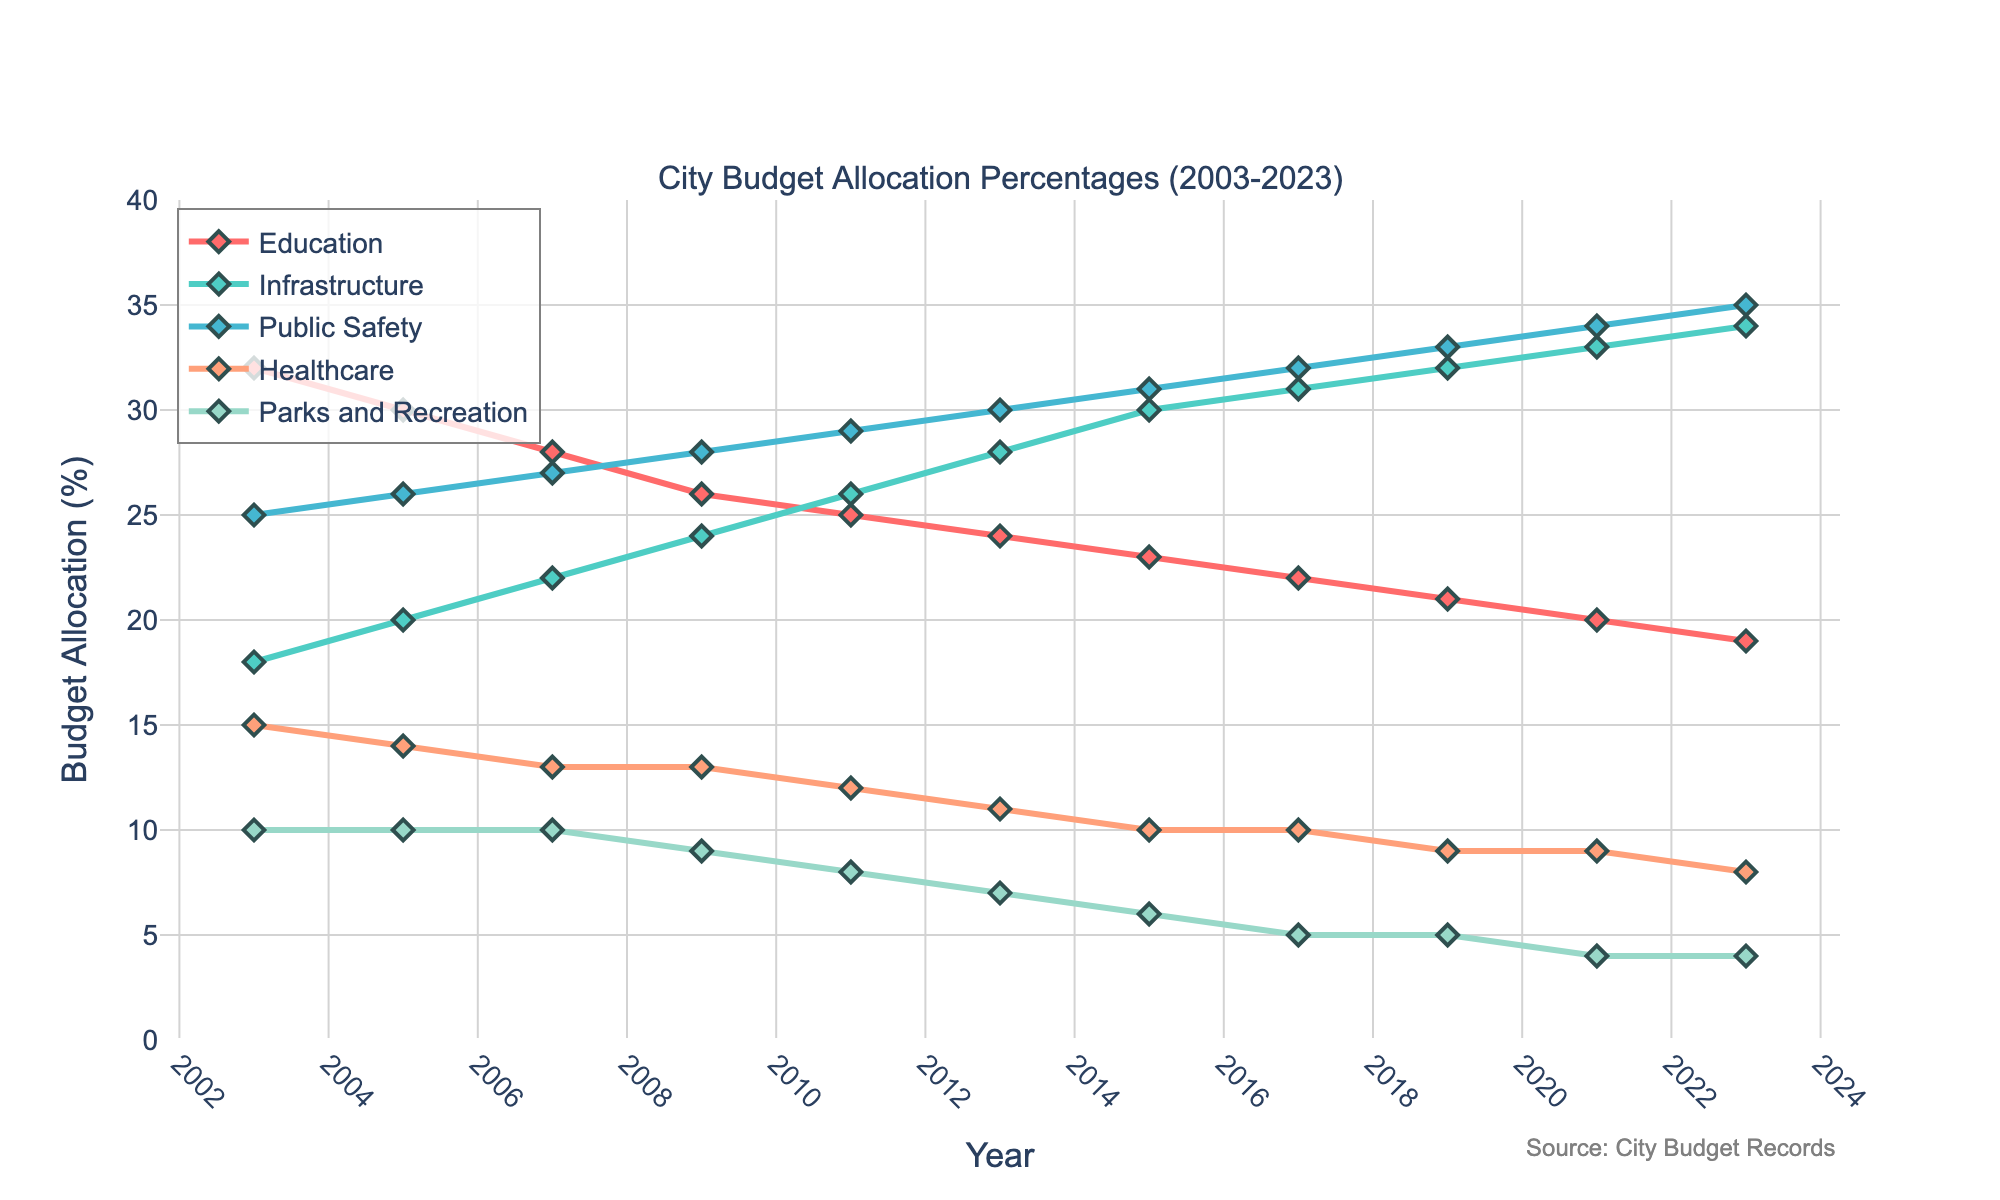What's the trend in budget allocation for the Education sector over the 20 years? The Education sector shows a consistently decreasing trend in budget allocation percentages, starting at 32% in 2003 and decreasing steadily to 19% in 2023.
Answer: Decreasing trend Which sector has seen the most significant increase in budget allocation from 2003 to 2023? Public Safety has seen the most significant increase in budget allocation, rising from 25% in 2003 to 35% in 2023, an increase of 10 percentage points.
Answer: Public Safety In which year did Infrastructure surpass Education in budget allocation for the first time? By examining the plot, Infrastructure first surpassed Education in budget allocation in 2005, where Infrastructure reached 20% and Education dropped to 30%.
Answer: 2005 Is Healthcare's budget allocation higher or lower than Parks and Recreation in 2023? In 2023, Healthcare's budget allocation is 8%, while Parks and Recreation is 4%. Therefore, Healthcare's budget allocation is higher than Parks and Recreation.
Answer: Higher What's the average budget allocation for Parks and Recreation over the depicted period? Summing up the budget allocation percentages for Parks and Recreation over each year provided: (10 + 10 + 10 + 9 + 8 + 7 + 6 + 5 + 5 + 4 + 4 = 78). The period covers 11 years, so the average is 78/11 ≈ 7.09%.
Answer: 7.09% What is the difference between the highest and lowest budget allocations for Education throughout these years? The highest budget allocation for Education is 32% (2003) and the lowest is 19% (2023). The difference is 32% - 19% = 13%.
Answer: 13% Did any sector see an increase in each consecutive two-year period? Public Safety saw an increase in each consecutive two-year period, rising steadily from 25% in 2003 to 35% in 2023.
Answer: Public Safety What were the budget allocations for Infrastructure and Public Safety in 2015, and which one was higher? In 2015, Infrastructure had a budget allocation of 30% and Public Safety had 31%. Public Safety's allocation was higher than Infrastructure.
Answer: Public Safety In which year did Parks and Recreation have its highest budget allocation, and what was it? Parks and Recreation had its highest budget allocation of 10% in the years 2003, 2005, and 2007.
Answer: 2003, 2005, 2007 What's the combined budget allocation for Healthcare and Parks and Recreation in 2021, and how does it compare to their combined allocation in 2003? In 2021, Healthcare is at 9% and Parks and Recreation at 4%, giving a combined allocation of 13%. In 2003, Healthcare was at 15% and Parks and Recreation at 10%, giving a combined allocation of 25%. Therefore, the combined allocation decreased from 25% in 2003 to 13% in 2021.
Answer: Decreased 